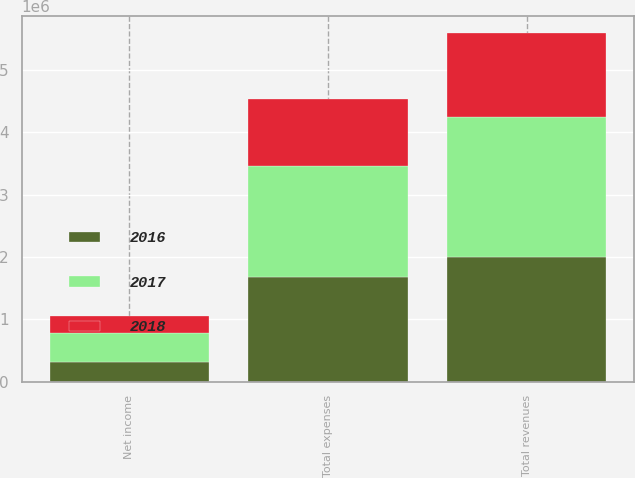Convert chart to OTSL. <chart><loc_0><loc_0><loc_500><loc_500><stacked_bar_chart><ecel><fcel>Total revenues<fcel>Total expenses<fcel>Net income<nl><fcel>2017<fcel>2.25535e+06<fcel>1.77916e+06<fcel>476192<nl><fcel>2016<fcel>1.99401e+06<fcel>1.68428e+06<fcel>309738<nl><fcel>2018<fcel>1.34066e+06<fcel>1.07847e+06<fcel>262192<nl></chart> 